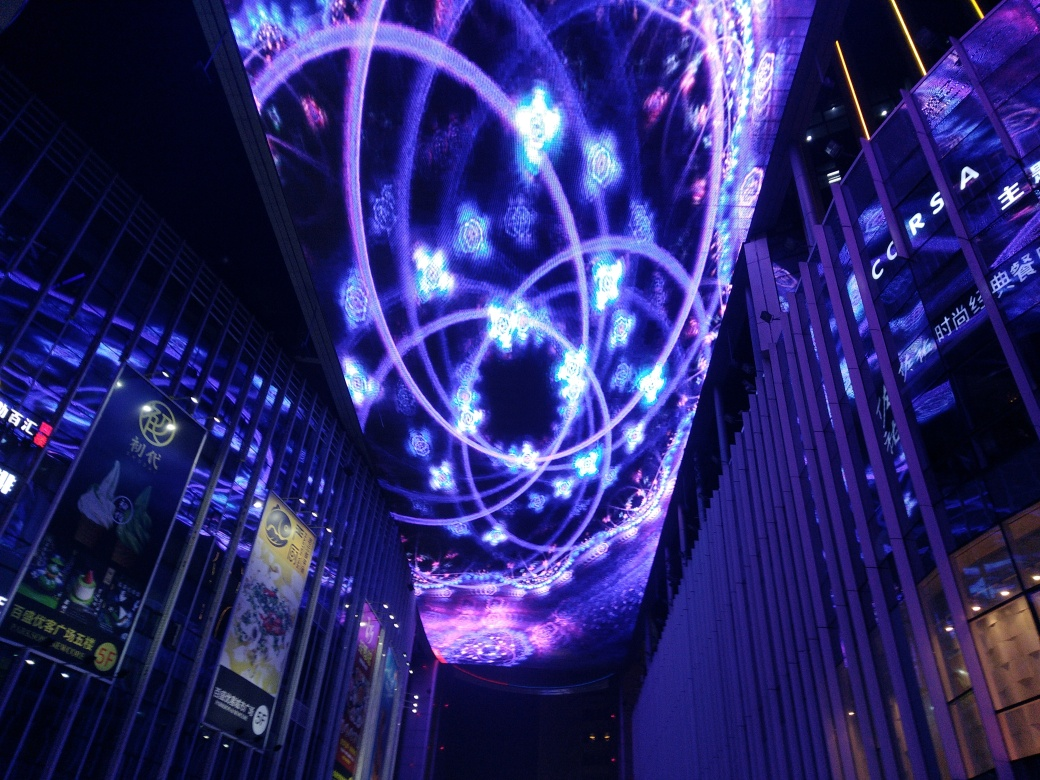Is the lighting fairly sufficient in the image?
A. Yes
B. No
Answer with the option's letter from the given choices directly.
 A. 